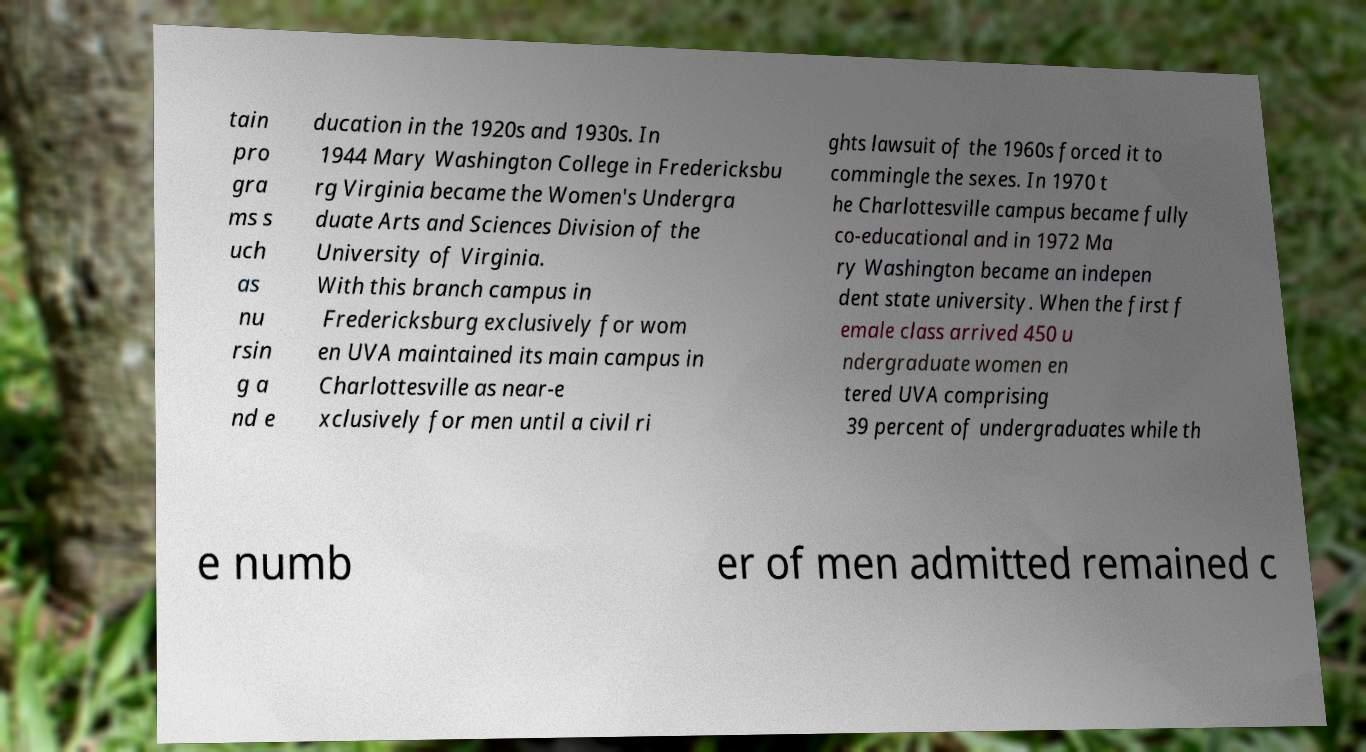Could you extract and type out the text from this image? tain pro gra ms s uch as nu rsin g a nd e ducation in the 1920s and 1930s. In 1944 Mary Washington College in Fredericksbu rg Virginia became the Women's Undergra duate Arts and Sciences Division of the University of Virginia. With this branch campus in Fredericksburg exclusively for wom en UVA maintained its main campus in Charlottesville as near-e xclusively for men until a civil ri ghts lawsuit of the 1960s forced it to commingle the sexes. In 1970 t he Charlottesville campus became fully co-educational and in 1972 Ma ry Washington became an indepen dent state university. When the first f emale class arrived 450 u ndergraduate women en tered UVA comprising 39 percent of undergraduates while th e numb er of men admitted remained c 